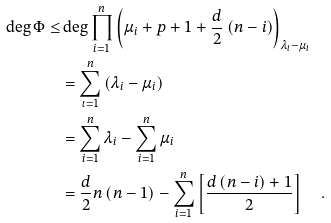Convert formula to latex. <formula><loc_0><loc_0><loc_500><loc_500>\deg \Phi \leq & \deg \prod _ { i = 1 } ^ { n } \left ( \mu _ { i } + p + 1 + \frac { d } { 2 } \left ( n - i \right ) \right ) _ { \lambda _ { i } - \mu _ { i } } \\ & = \sum _ { \iota = 1 } ^ { n } \left ( \lambda _ { i } - \mu _ { i } \right ) \\ & = \sum _ { i = 1 } ^ { n } \lambda _ { i } - \sum _ { i = 1 } ^ { n } \mu _ { i } \\ & = \frac { d } { 2 } n \left ( n - 1 \right ) - \sum _ { i = 1 } ^ { n } \left [ \frac { d \left ( n - i \right ) + 1 } { 2 } \right ] \quad .</formula> 